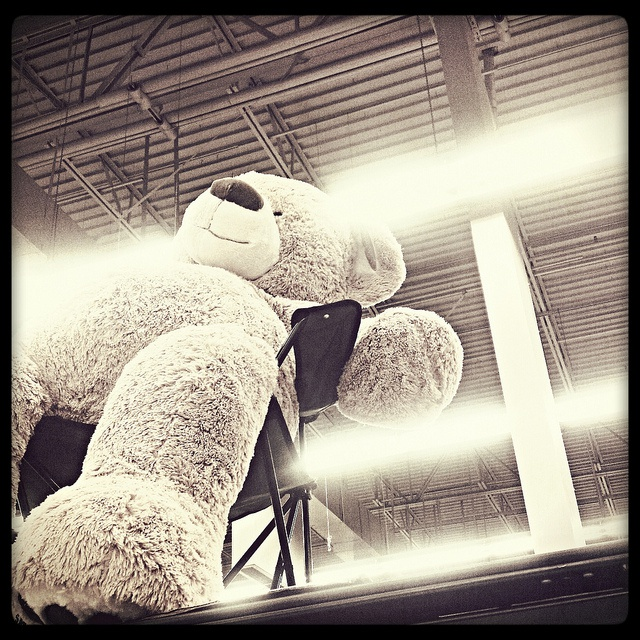Describe the objects in this image and their specific colors. I can see teddy bear in black, beige, and tan tones and chair in black, gray, and beige tones in this image. 